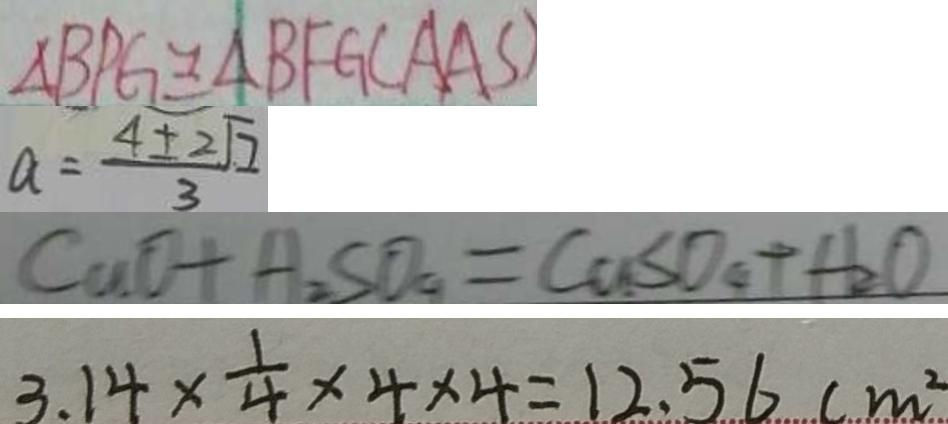<formula> <loc_0><loc_0><loc_500><loc_500>\Delta B P G \cong \Delta B F G ( A A S ) 
 a = \frac { 4 \pm 2 \sqrt { 7 } } { 3 } 
 C u O + H _ { 2 } S O _ { 4 } = C a S O _ { 4 } + H _ { 2 } O 
 3 . 1 4 \times \frac { 1 } { 4 } \times 4 \times 4 = 1 2 . 5 6 ( m ^ { 2 }</formula> 